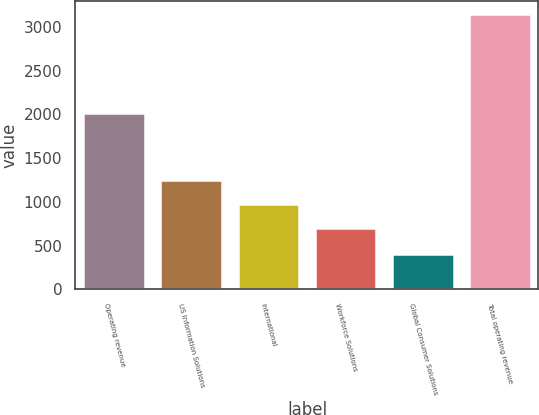Convert chart to OTSL. <chart><loc_0><loc_0><loc_500><loc_500><bar_chart><fcel>Operating revenue<fcel>US Information Solutions<fcel>International<fcel>Workforce Solutions<fcel>Global Consumer Solutions<fcel>Total operating revenue<nl><fcel>2016<fcel>1250.66<fcel>976.43<fcel>702.2<fcel>402.6<fcel>3144.9<nl></chart> 